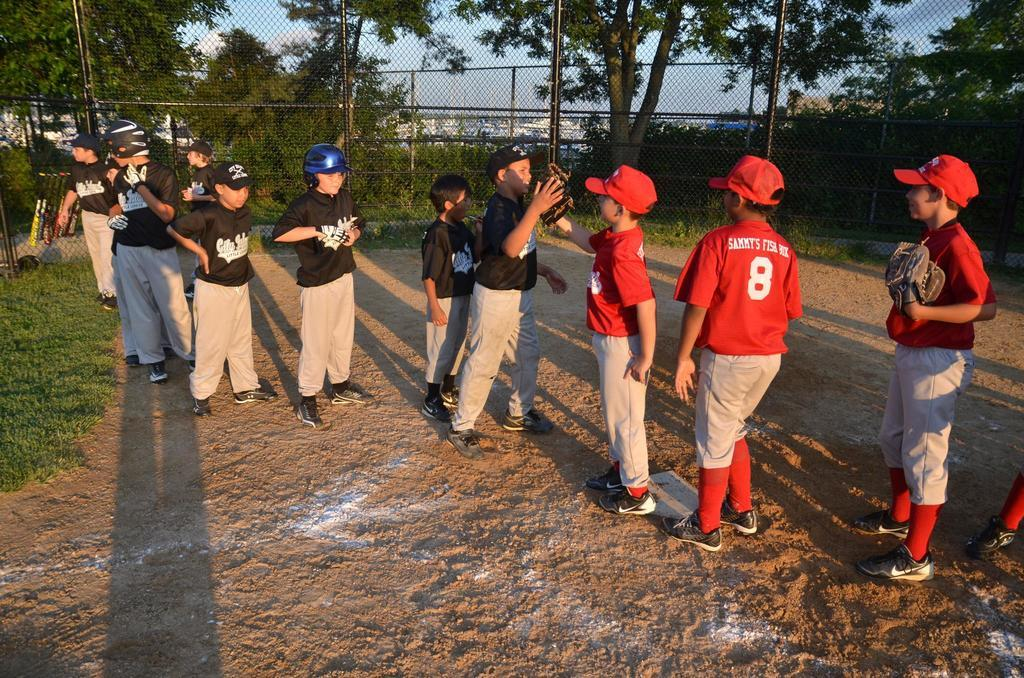How many people are in the image? There is a group of people in the image, but the exact number is not specified. What is the surface the people are standing on? The people are standing on the ground. What type of vegetation can be seen in the background of the image? There are trees in the background of the image. What type of architectural feature is present in the background of the image? There are fences in the background of the image. What else can be seen in the background of the image? There are bats and some objects in the background of the image. What is visible in the sky in the image? The sky is visible in the background of the image. What type of juice is being served to the people in the image? There is no mention of juice or any beverage being served in the image. 